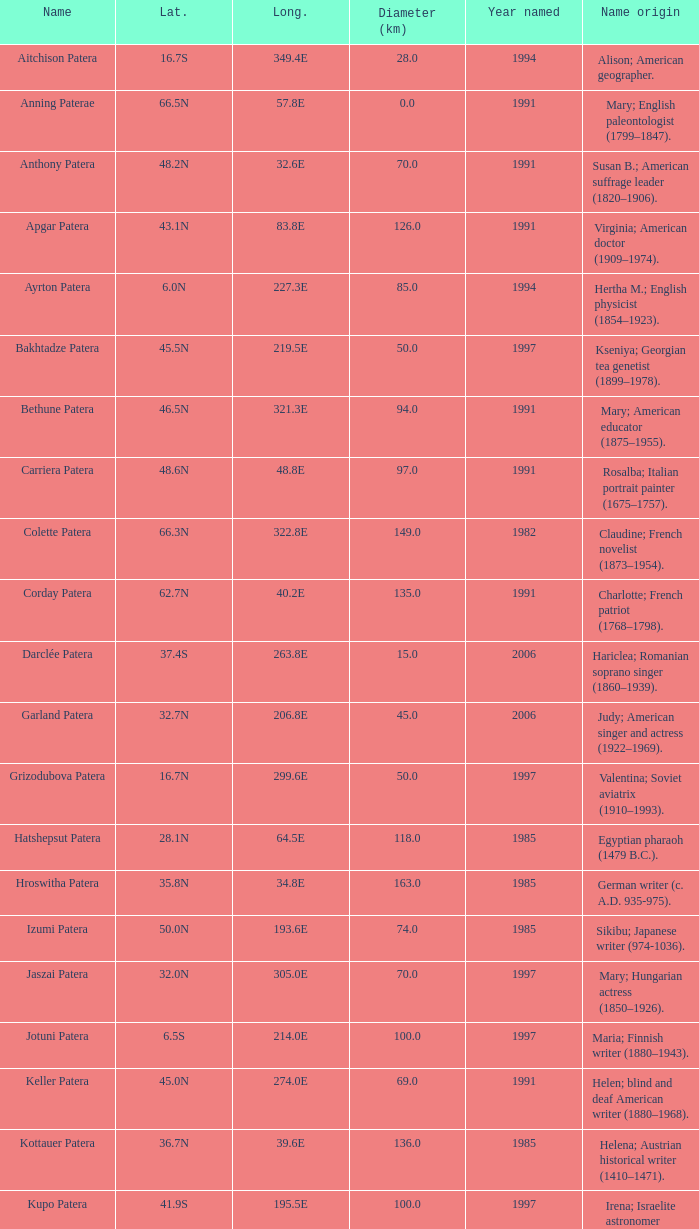What is the origin of the name of Keller Patera?  Helen; blind and deaf American writer (1880–1968). 